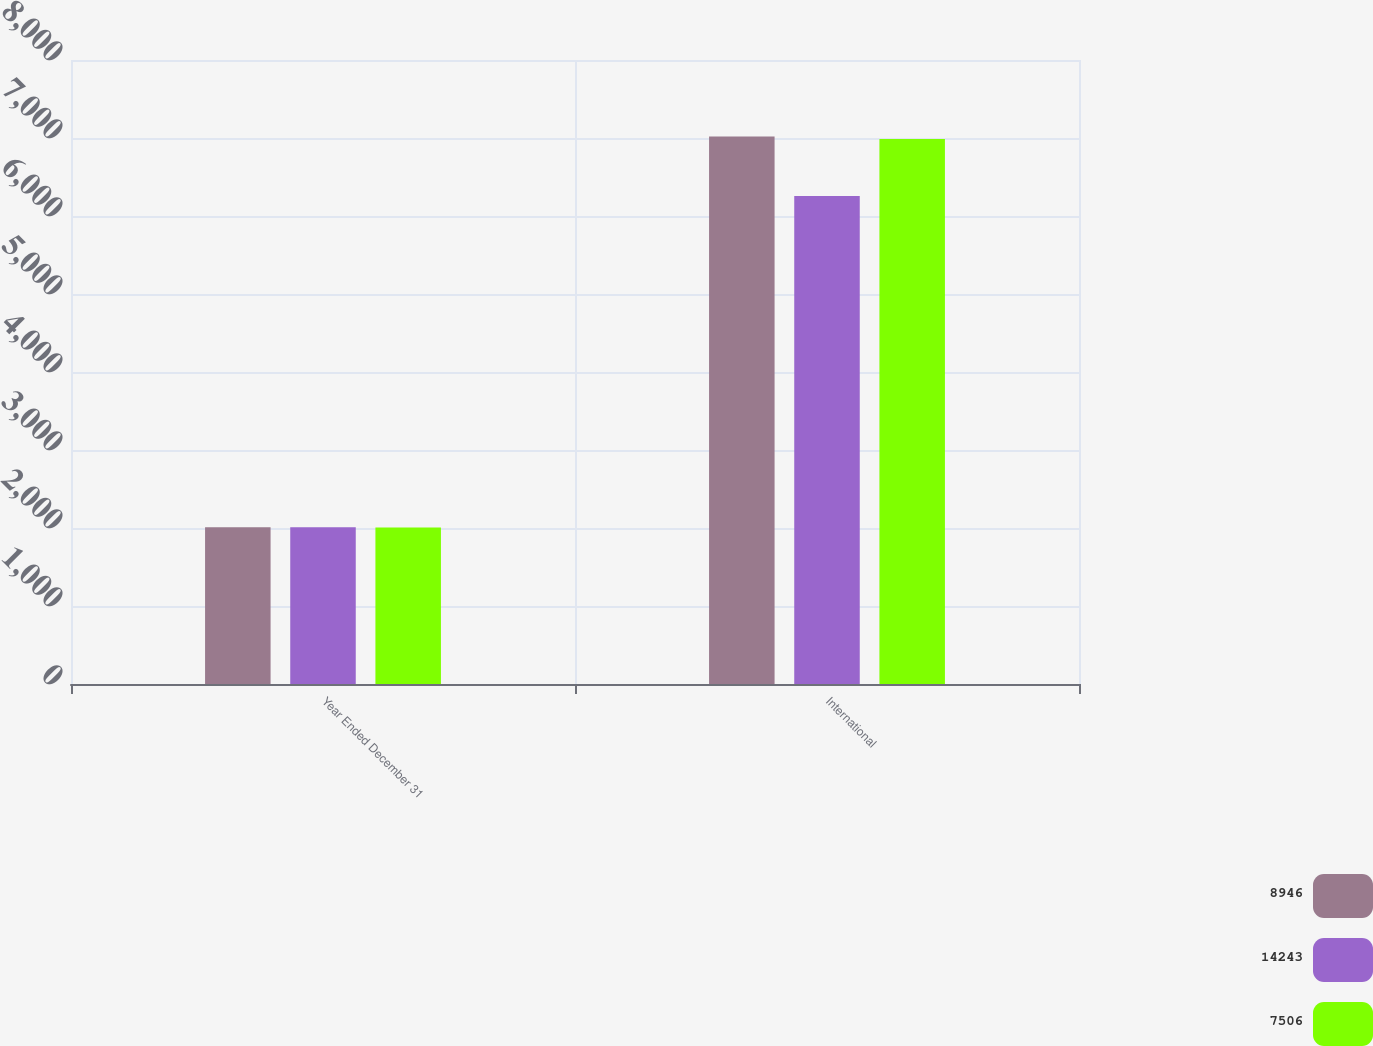Convert chart. <chart><loc_0><loc_0><loc_500><loc_500><stacked_bar_chart><ecel><fcel>Year Ended December 31<fcel>International<nl><fcel>8946<fcel>2010<fcel>7019<nl><fcel>14243<fcel>2009<fcel>6255<nl><fcel>7506<fcel>2008<fcel>6987<nl></chart> 